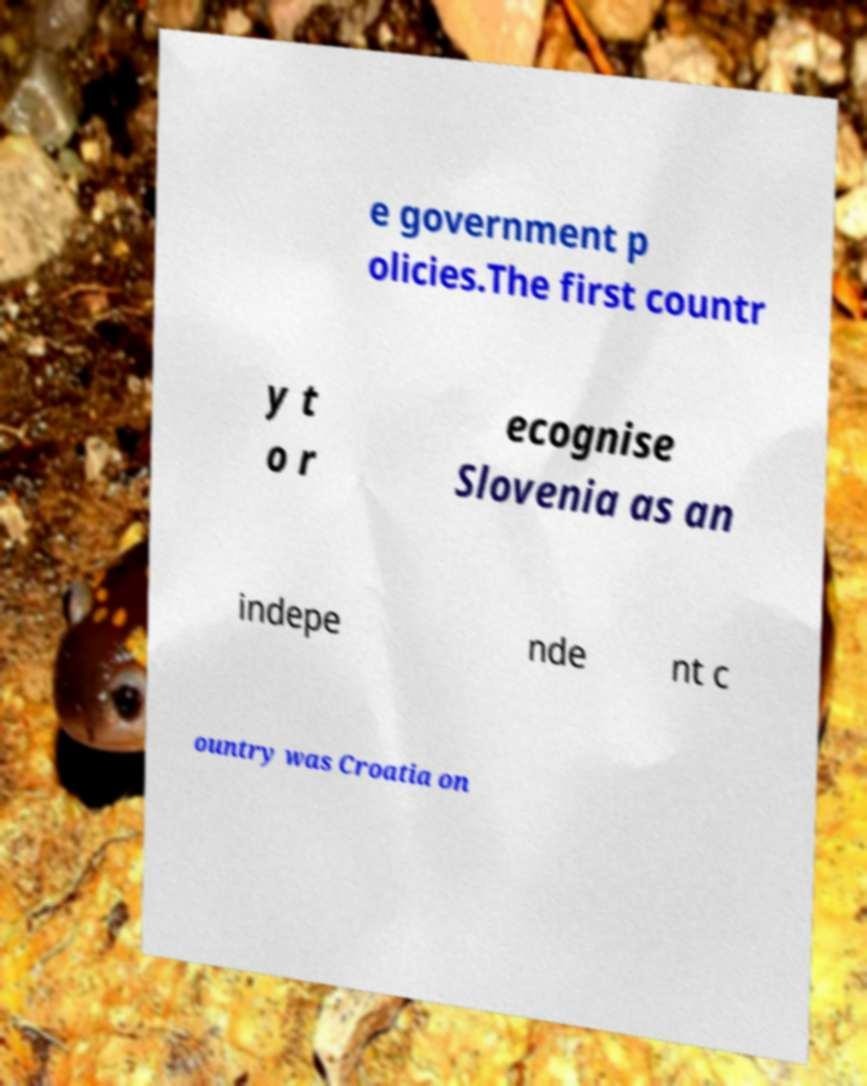What messages or text are displayed in this image? I need them in a readable, typed format. e government p olicies.The first countr y t o r ecognise Slovenia as an indepe nde nt c ountry was Croatia on 